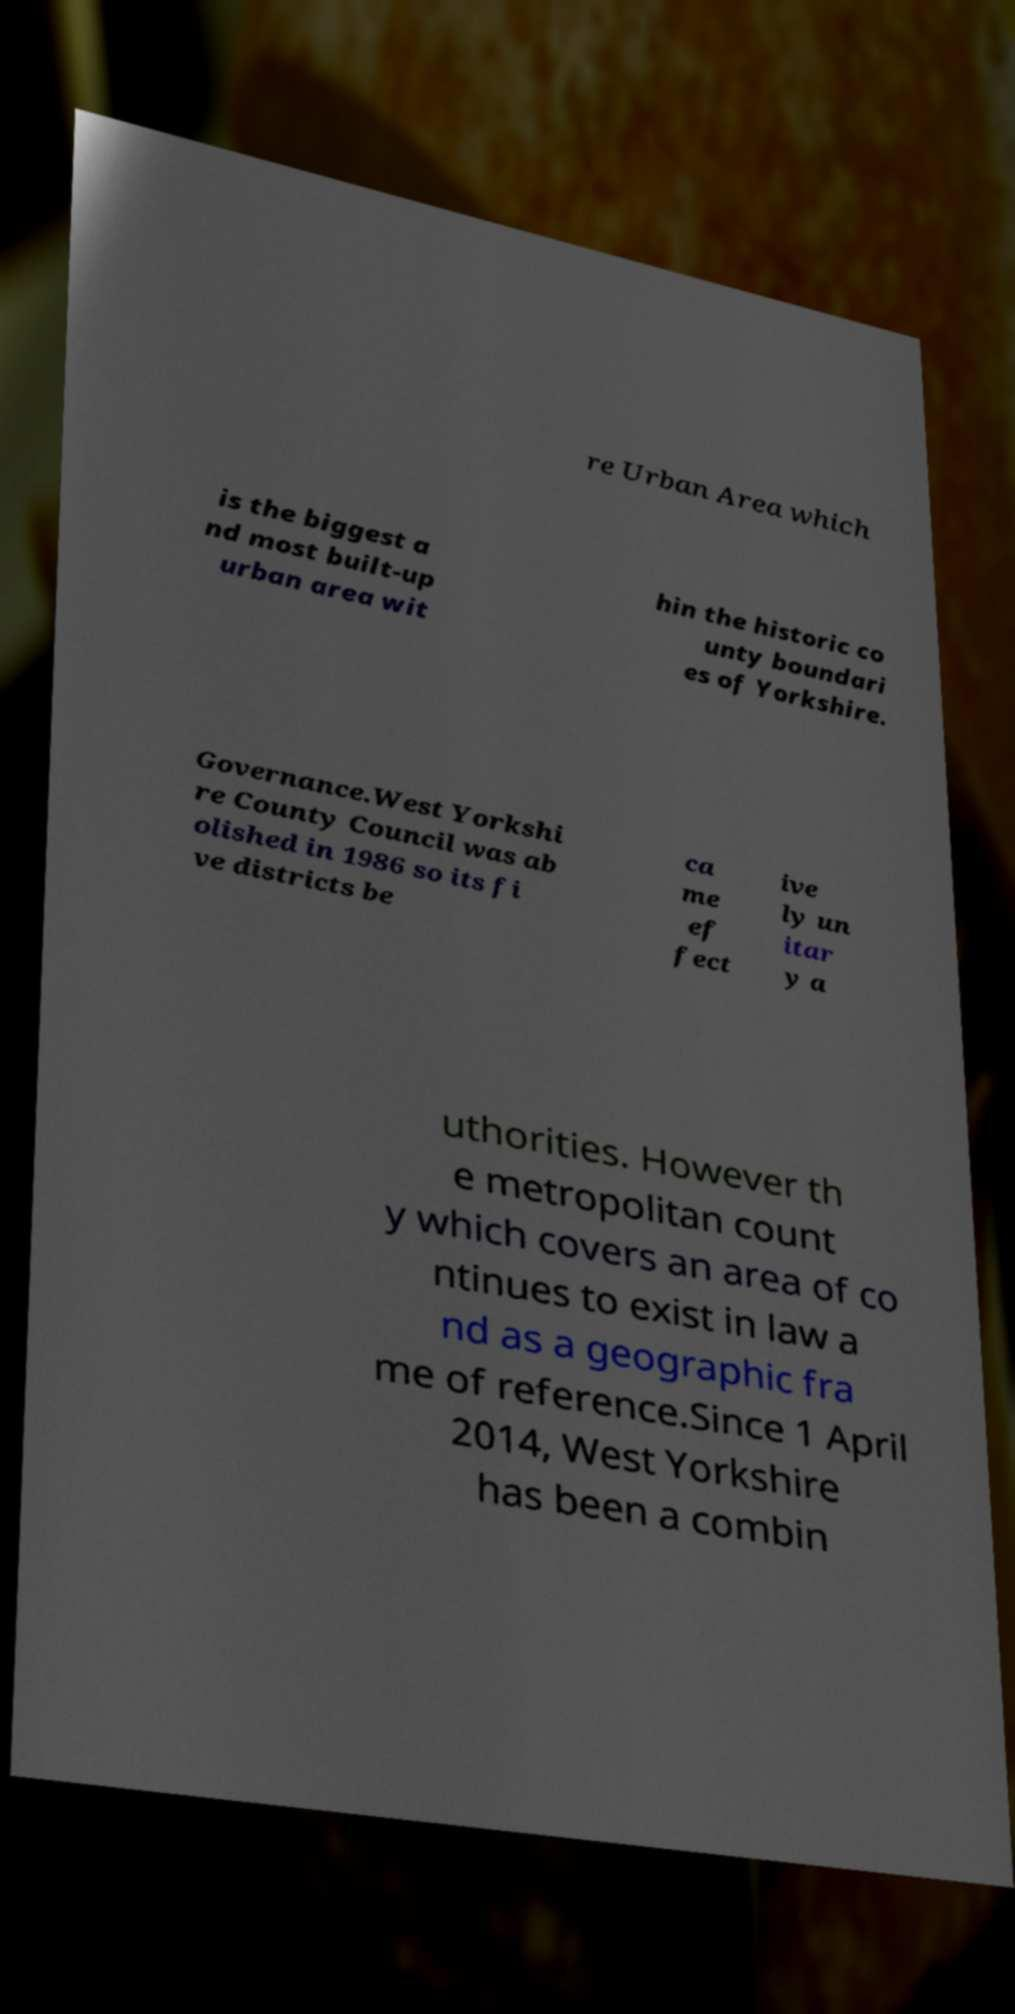What messages or text are displayed in this image? I need them in a readable, typed format. re Urban Area which is the biggest a nd most built-up urban area wit hin the historic co unty boundari es of Yorkshire. Governance.West Yorkshi re County Council was ab olished in 1986 so its fi ve districts be ca me ef fect ive ly un itar y a uthorities. However th e metropolitan count y which covers an area of co ntinues to exist in law a nd as a geographic fra me of reference.Since 1 April 2014, West Yorkshire has been a combin 